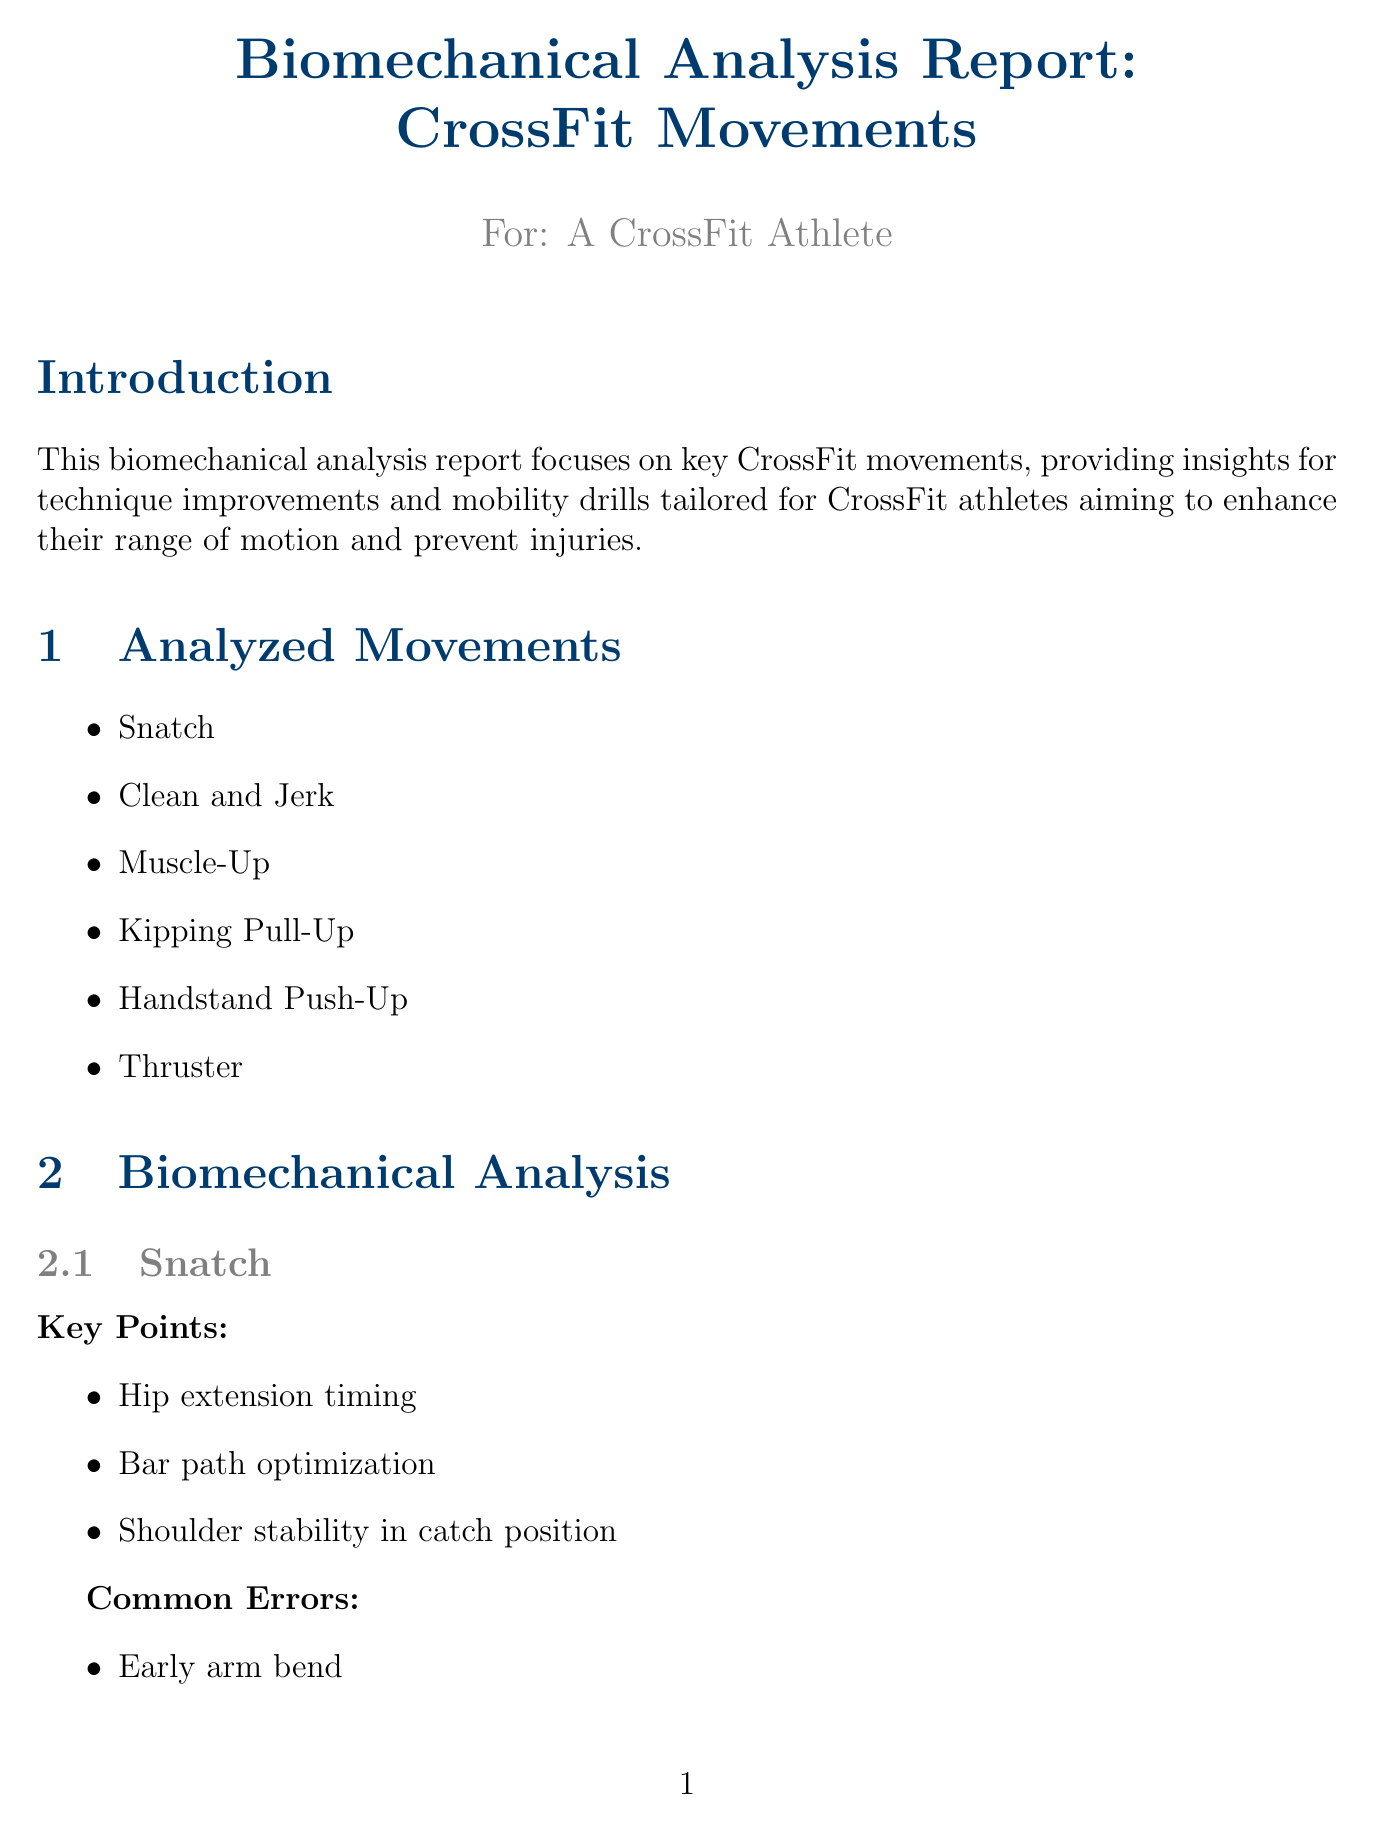What are the key points for the Snatch movement? The key points for the Snatch movement are listed in the biomechanical analysis section of the report.
Answer: Hip extension timing, Bar path optimization, Shoulder stability in catch position What is one common error in the Muscle-Up? The common errors for the Muscle-Up are specified in the biomechanical analysis section of the report.
Answer: Insufficient kip How many sets and reps are recommended for Shoulder Dislocates? The recommended frequency for Shoulder Dislocates is provided in the mobility drills section of the report.
Answer: 3 sets of 10 reps, daily What type of recovery strategy is advised in the report? The injury prevention strategies section outlines various strategies, including types of recovery.
Answer: Active Recovery How many analyzed movements are listed in the report? The number of analyzed movements is indicated in the analyzed movements section of the document.
Answer: 6 